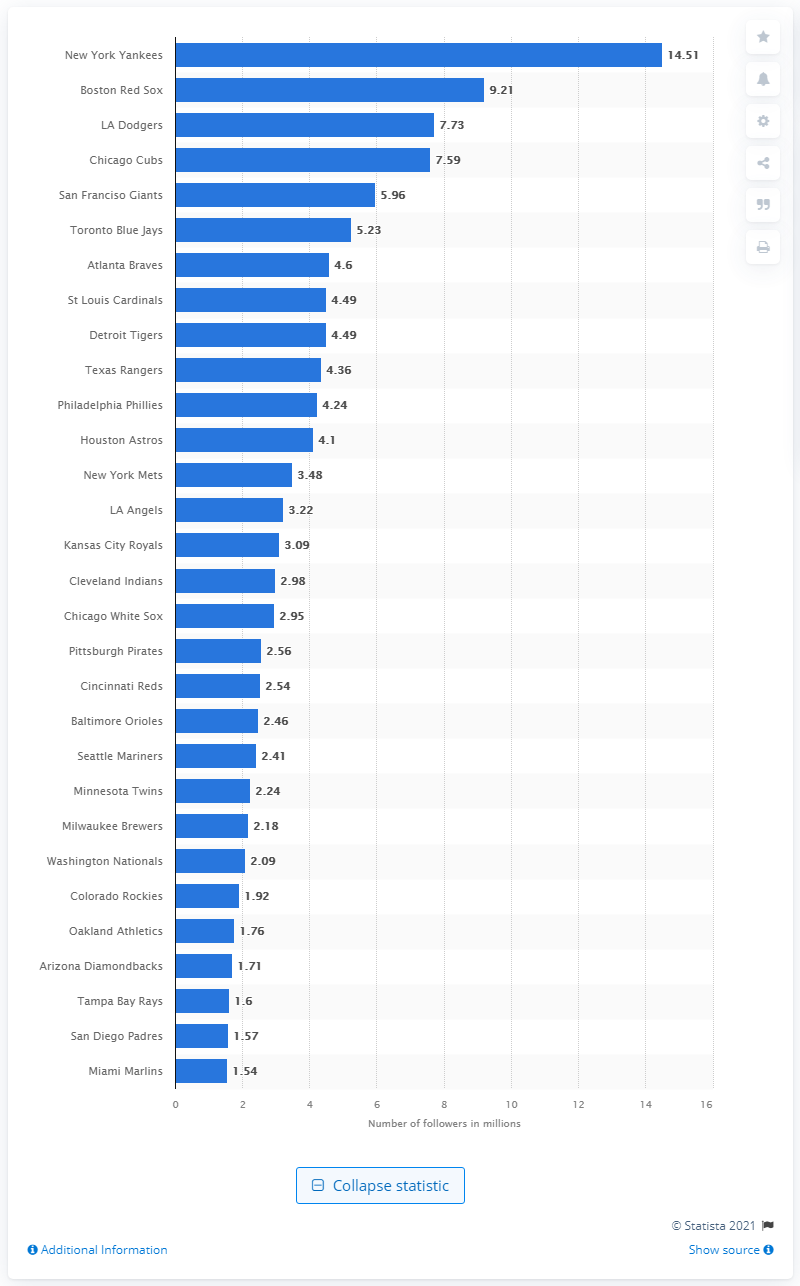List a handful of essential elements in this visual. In 2019, the New York Yankees had 14,510 followers. 